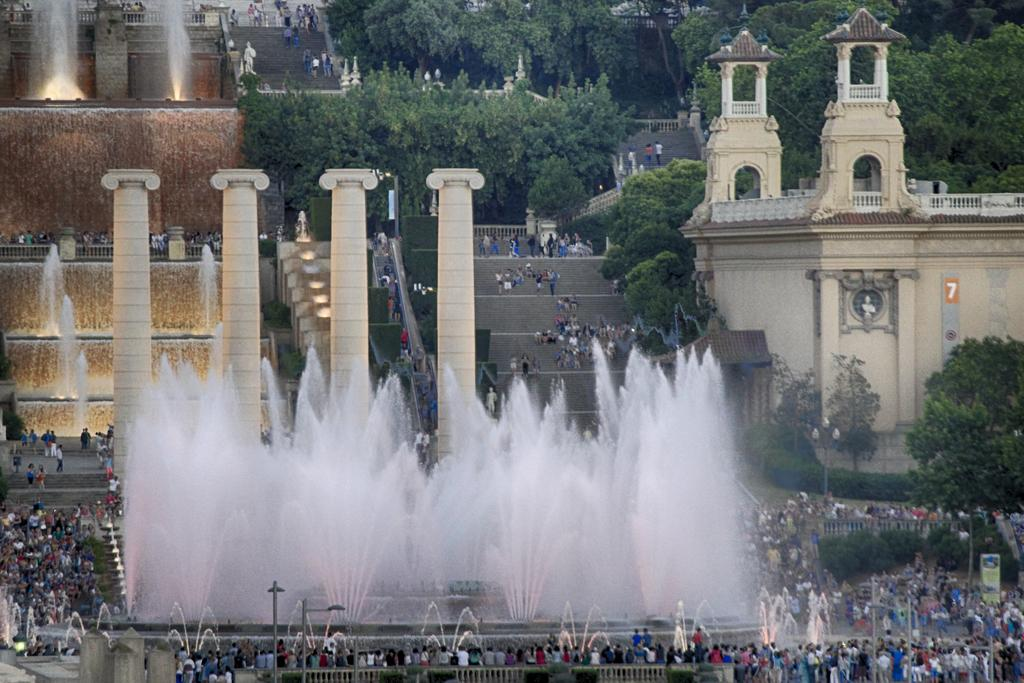How many people can be seen at the bottom of the image? There are many people at the bottom of the image. What can be found in the image besides the people at the bottom? There are fountains in the image. Can you describe the background of the image? In the background, there are people, fountains, water, steps, hoardings, light poles, fences, and trees. How does the stranger react to the shocking event in the wilderness in the image? There is no stranger or shocking event in the wilderness depicted in the image. 